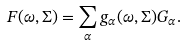Convert formula to latex. <formula><loc_0><loc_0><loc_500><loc_500>F ( \omega , \Sigma ) = \sum _ { \alpha } g _ { \alpha } ( \omega , \Sigma ) G _ { \alpha } .</formula> 